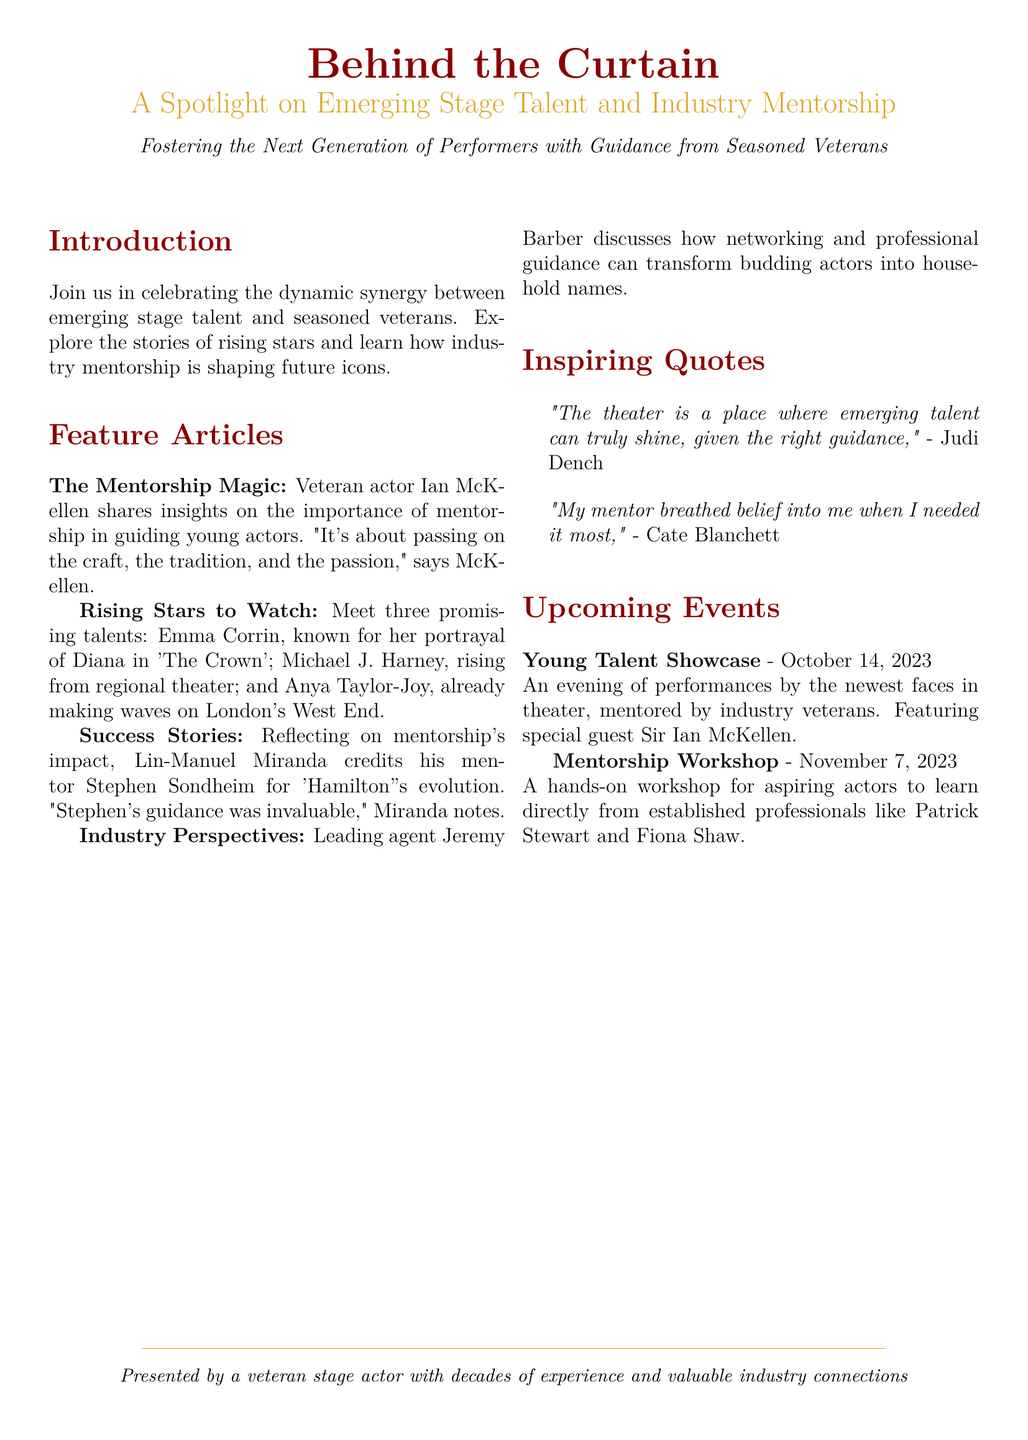What is the title of the event? The title is prominently featured at the top of the document and is "Behind the Curtain."
Answer: Behind the Curtain Who is quoted about the importance of mentorship? The document contains a quote from veteran actor Ian McKellen discussing mentorship.
Answer: Ian McKellen What date is the Young Talent Showcase scheduled for? The specific date for the Young Talent Showcase is listed in the Upcoming Events section.
Answer: October 14, 2023 Which industry veteran is mentioned as a special guest for the Young Talent Showcase? The document notes a special guest at the event, highlighting their significance.
Answer: Sir Ian McKellen What notable work is Emma Corrin known for? Emma Corrin's well-known role is specifically identified in the document.
Answer: The Crown What workshop date is mentioned in the document? The document includes the date for the Mentorship Workshop, indicating its relevance.
Answer: November 7, 2023 Who credited his mentor Stephen Sondheim for 'Hamilton's' evolution? The document discusses a success story involving a notable figure and their mentor.
Answer: Lin-Manuel Miranda What is the main theme of the event? The underlying theme is elaborated upon in the introductory section of the document.
Answer: Mentorship Who discusses the importance of networking for aspiring actors? A leading agent's perspective is shared in the Industry Perspectives section.
Answer: Jeremy Barber 